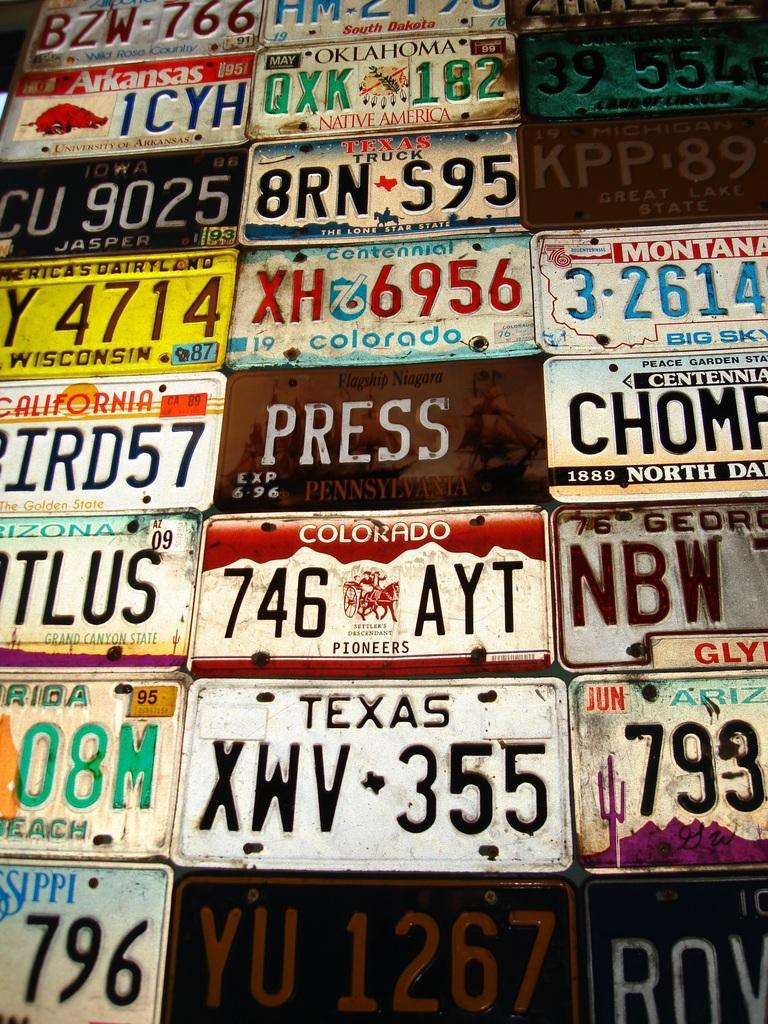How would you summarize this image in a sentence or two? In this image there are some name plates, on the plates there is text and some numbers. 